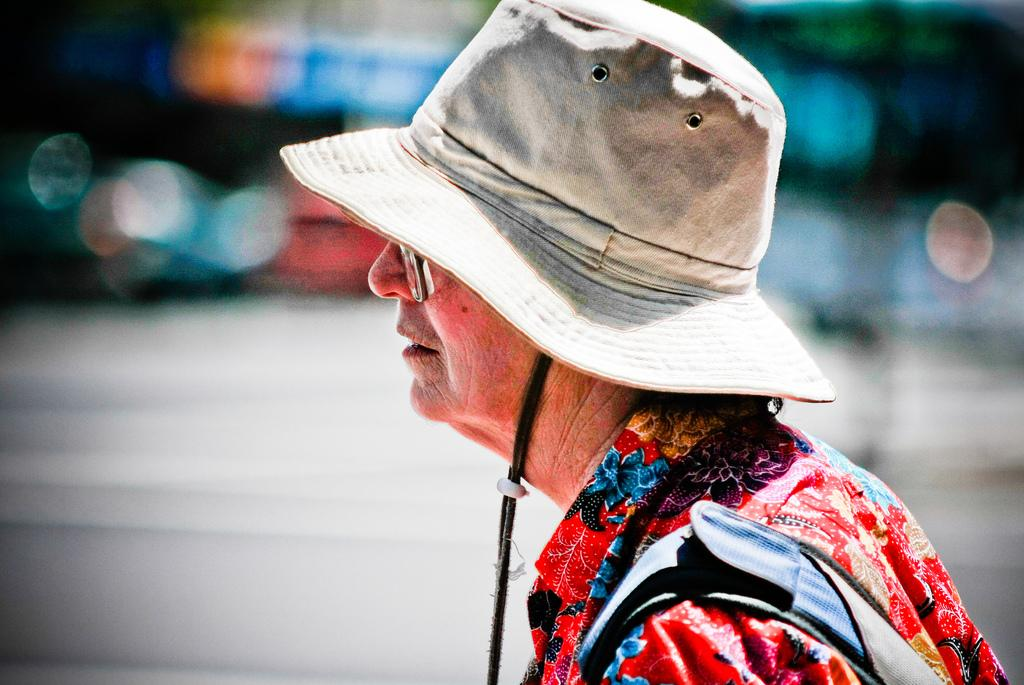Who or what is the main subject of the image? There is a person in the image. What is the person wearing on their head? The person is wearing a hat. Can you describe the background of the image? The background of the image is blurred. What type of food is the person cooking in the image? There is no indication in the image that the person is cooking any food. 